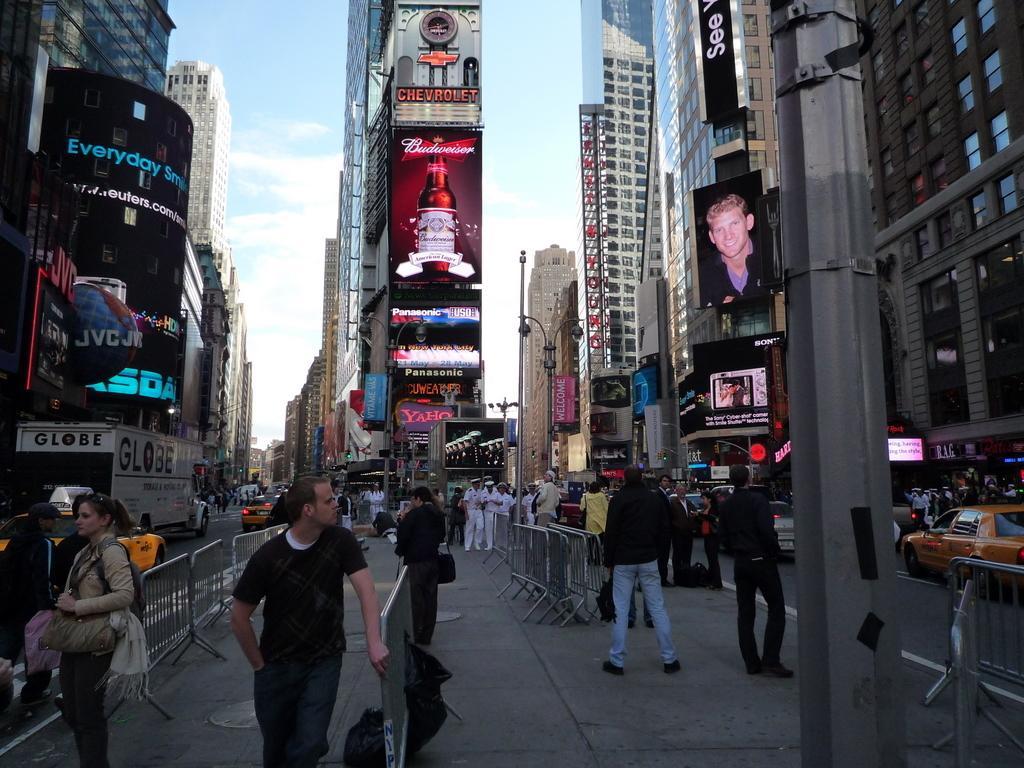Could you give a brief overview of what you see in this image? In this image we can see these people are on the sidewalk, we can see the barriers, light poles, vehicles moving on the road, we can see hoardings, tower buildings, pole and the sky with clouds in the background. 